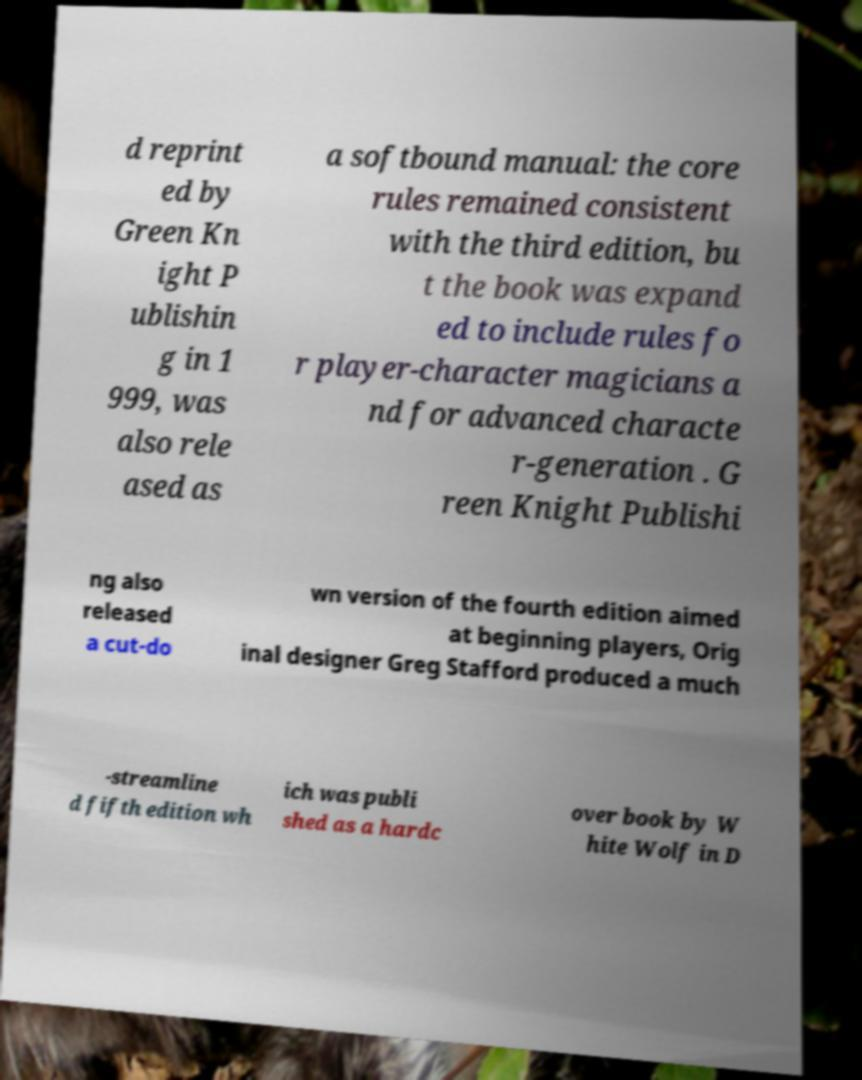I need the written content from this picture converted into text. Can you do that? d reprint ed by Green Kn ight P ublishin g in 1 999, was also rele ased as a softbound manual: the core rules remained consistent with the third edition, bu t the book was expand ed to include rules fo r player-character magicians a nd for advanced characte r-generation . G reen Knight Publishi ng also released a cut-do wn version of the fourth edition aimed at beginning players, Orig inal designer Greg Stafford produced a much -streamline d fifth edition wh ich was publi shed as a hardc over book by W hite Wolf in D 